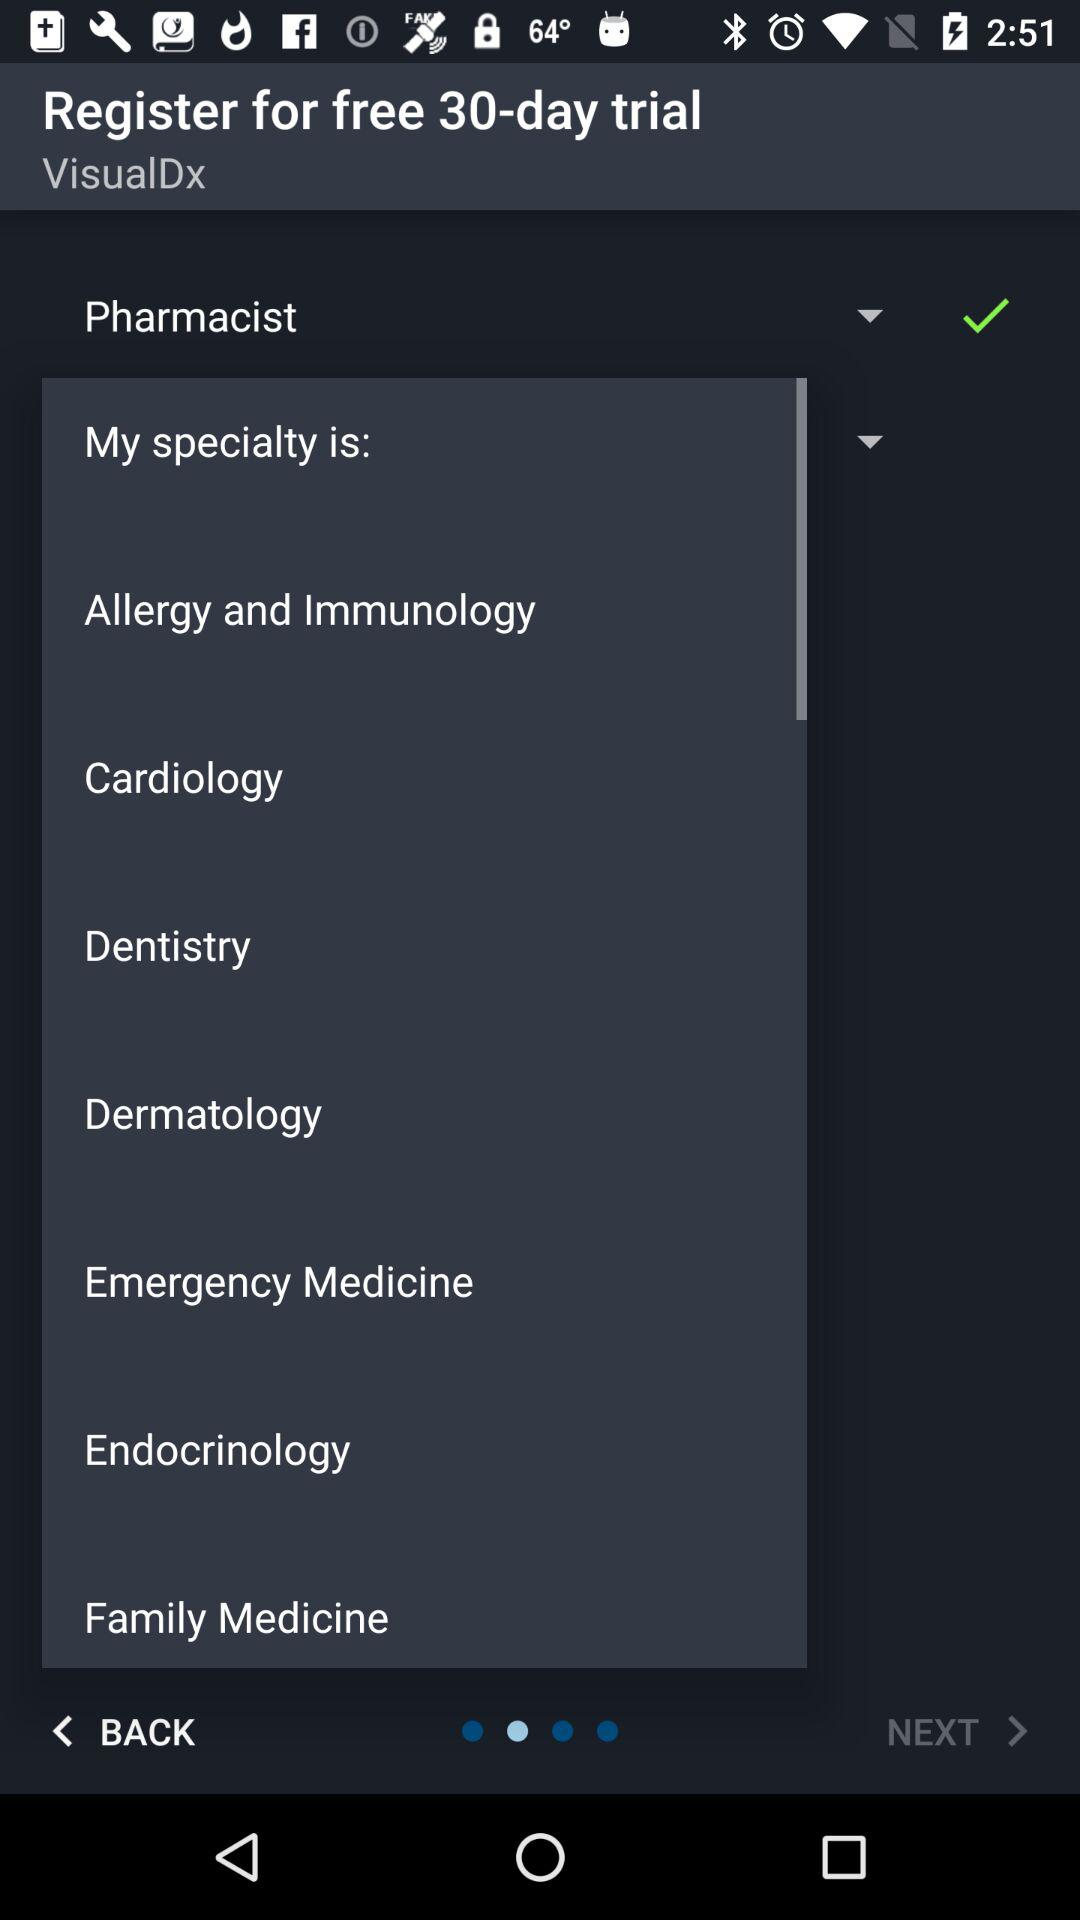What is the name of the application? The name of the application is "VisualDx". 